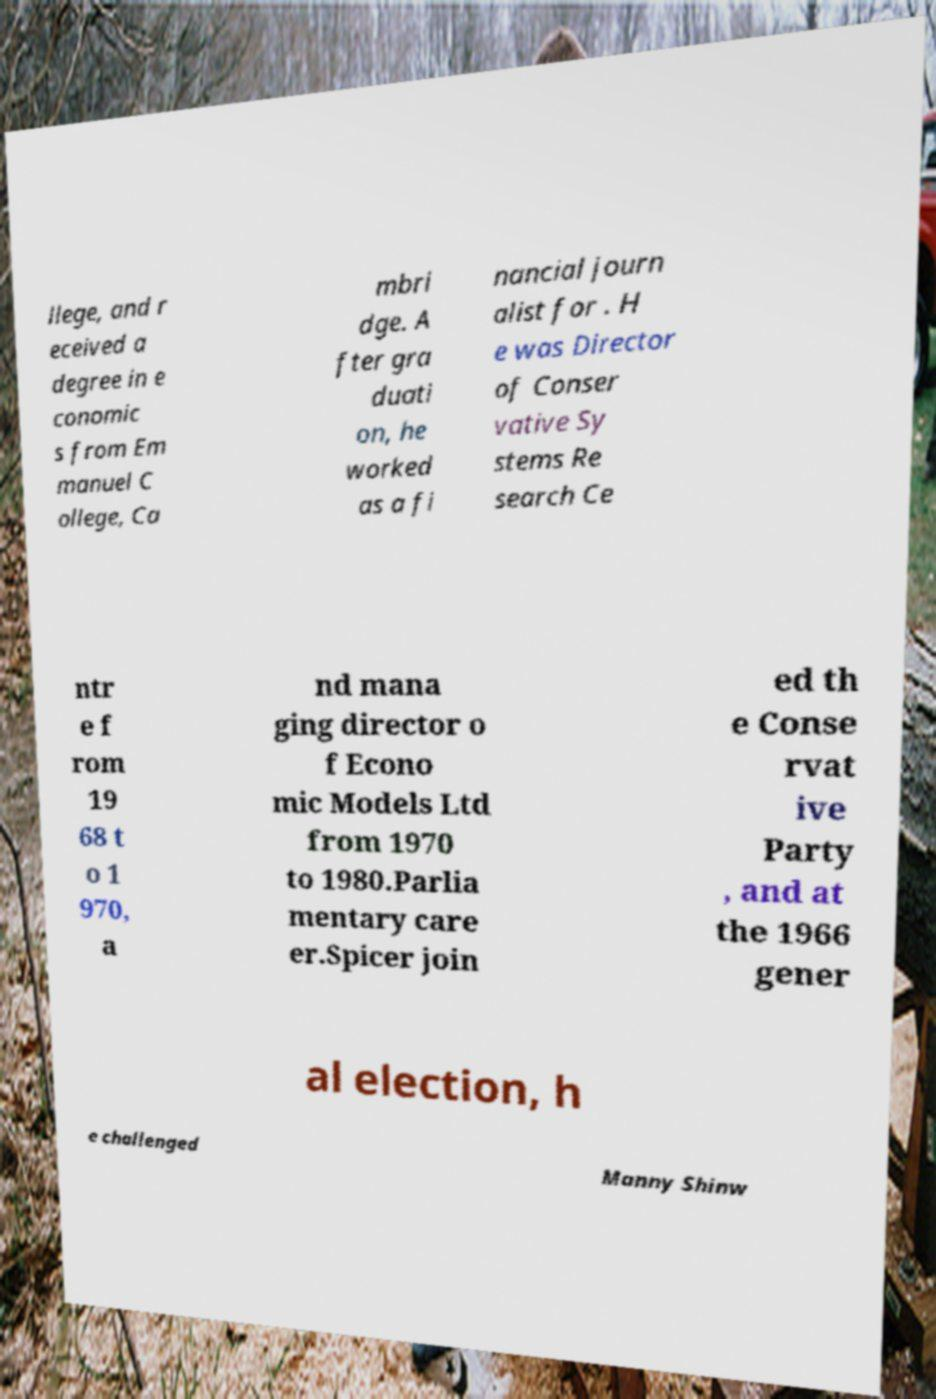Can you accurately transcribe the text from the provided image for me? llege, and r eceived a degree in e conomic s from Em manuel C ollege, Ca mbri dge. A fter gra duati on, he worked as a fi nancial journ alist for . H e was Director of Conser vative Sy stems Re search Ce ntr e f rom 19 68 t o 1 970, a nd mana ging director o f Econo mic Models Ltd from 1970 to 1980.Parlia mentary care er.Spicer join ed th e Conse rvat ive Party , and at the 1966 gener al election, h e challenged Manny Shinw 